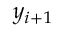Convert formula to latex. <formula><loc_0><loc_0><loc_500><loc_500>y _ { i + 1 }</formula> 